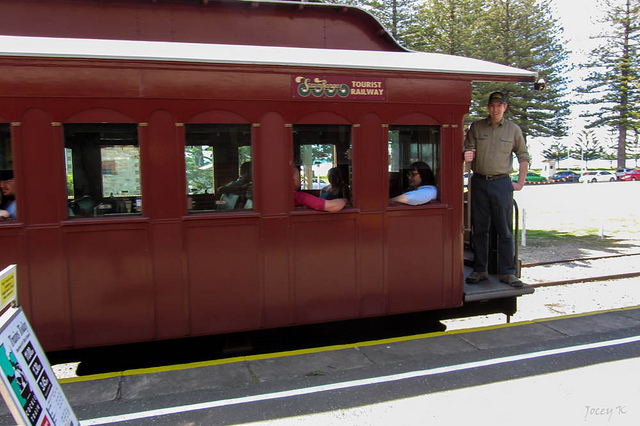What's happening in the scene? In the scene, we see a tourist railway car that is currently stationary. On the right side of the image, a man is standing on the platform of the railway car, dressed in trousers, and appearing to be an official or staff member. Inside the railway car, through the windows, we can see several passengers seated and looking out. On the leftmost side of the image, there's a signboard that is positioned vertically on the ground, displaying information likely relevant to the railway. The background showcases a bright day with a clear sky and some trees, contributing to a pleasant and serene outdoor setting. 